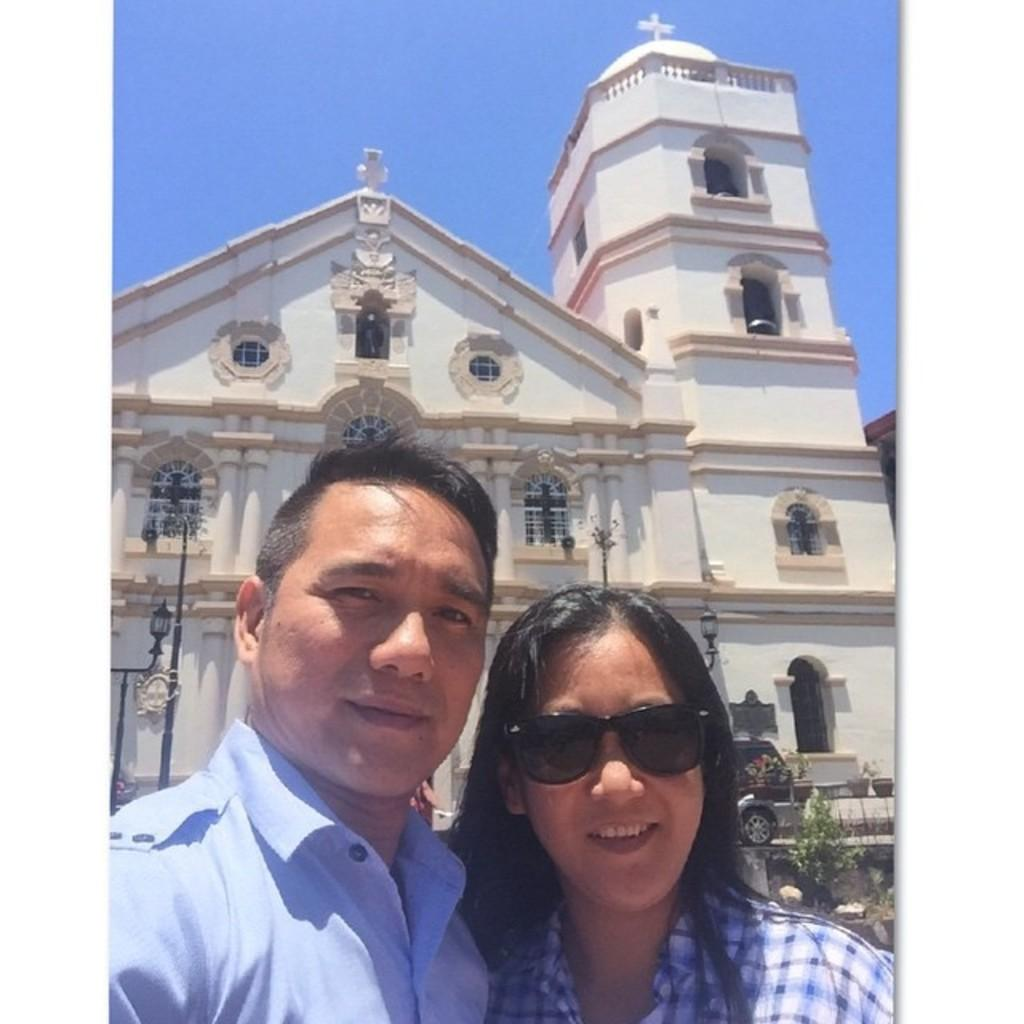Who are the people in the image? There is a lady and a guy in the image. What are the lady and guy doing in the image? The lady and guy are standing in front of a building. What other living creature is present in the image? There is a cat in the image. What type of natural elements can be seen in the image? There are trees in the image. What man-made objects are present in the image? There are poles in the image. What shape is the bucket in the image? There is no bucket present in the image. How many pears are visible in the image? There are no pears present in the image. 